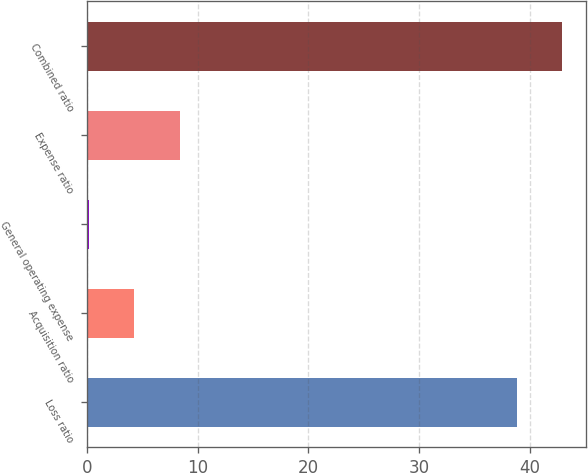<chart> <loc_0><loc_0><loc_500><loc_500><bar_chart><fcel>Loss ratio<fcel>Acquisition ratio<fcel>General operating expense<fcel>Expense ratio<fcel>Combined ratio<nl><fcel>38.8<fcel>4.29<fcel>0.2<fcel>8.38<fcel>42.89<nl></chart> 